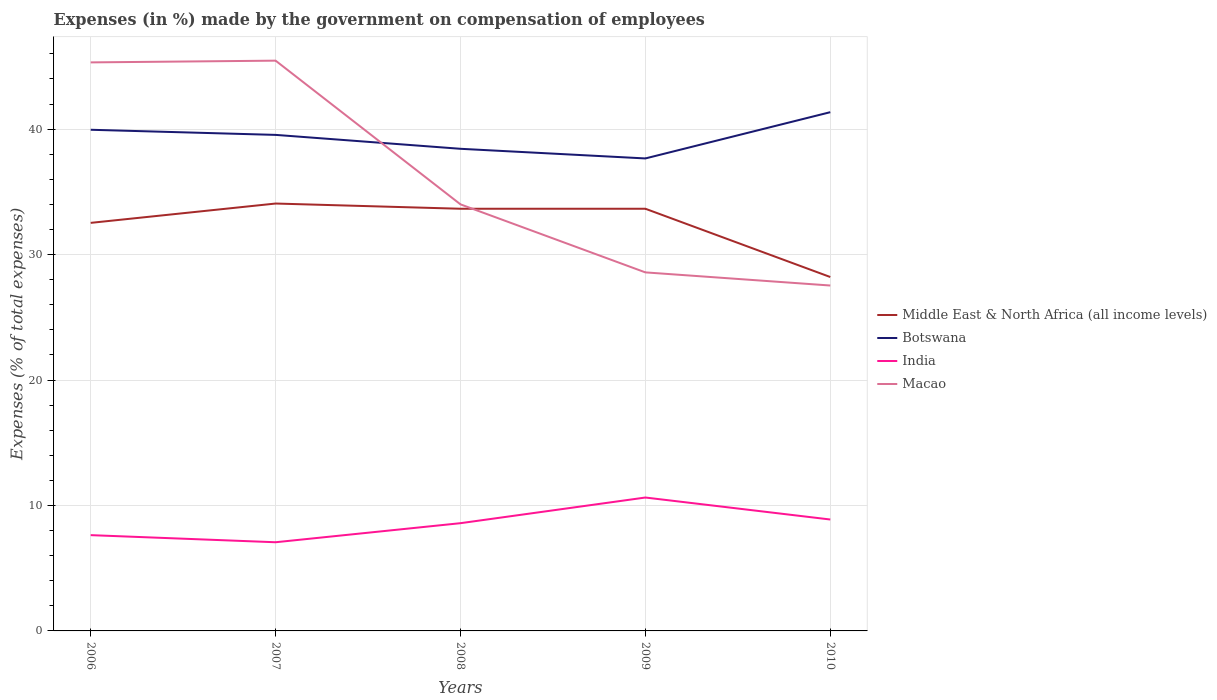Does the line corresponding to Botswana intersect with the line corresponding to Middle East & North Africa (all income levels)?
Offer a terse response. No. Is the number of lines equal to the number of legend labels?
Your response must be concise. Yes. Across all years, what is the maximum percentage of expenses made by the government on compensation of employees in Macao?
Your answer should be very brief. 27.54. What is the total percentage of expenses made by the government on compensation of employees in Botswana in the graph?
Offer a very short reply. 1.88. What is the difference between the highest and the second highest percentage of expenses made by the government on compensation of employees in Middle East & North Africa (all income levels)?
Ensure brevity in your answer.  5.86. What is the difference between the highest and the lowest percentage of expenses made by the government on compensation of employees in Botswana?
Provide a short and direct response. 3. How many lines are there?
Give a very brief answer. 4. Does the graph contain any zero values?
Offer a very short reply. No. Where does the legend appear in the graph?
Provide a succinct answer. Center right. How many legend labels are there?
Ensure brevity in your answer.  4. How are the legend labels stacked?
Make the answer very short. Vertical. What is the title of the graph?
Give a very brief answer. Expenses (in %) made by the government on compensation of employees. What is the label or title of the Y-axis?
Offer a very short reply. Expenses (% of total expenses). What is the Expenses (% of total expenses) of Middle East & North Africa (all income levels) in 2006?
Provide a succinct answer. 32.53. What is the Expenses (% of total expenses) in Botswana in 2006?
Give a very brief answer. 39.95. What is the Expenses (% of total expenses) of India in 2006?
Ensure brevity in your answer.  7.64. What is the Expenses (% of total expenses) of Macao in 2006?
Give a very brief answer. 45.32. What is the Expenses (% of total expenses) in Middle East & North Africa (all income levels) in 2007?
Your response must be concise. 34.07. What is the Expenses (% of total expenses) in Botswana in 2007?
Offer a very short reply. 39.54. What is the Expenses (% of total expenses) in India in 2007?
Your answer should be very brief. 7.07. What is the Expenses (% of total expenses) of Macao in 2007?
Make the answer very short. 45.46. What is the Expenses (% of total expenses) in Middle East & North Africa (all income levels) in 2008?
Your answer should be very brief. 33.65. What is the Expenses (% of total expenses) in Botswana in 2008?
Offer a very short reply. 38.43. What is the Expenses (% of total expenses) in India in 2008?
Ensure brevity in your answer.  8.59. What is the Expenses (% of total expenses) of Macao in 2008?
Your response must be concise. 34. What is the Expenses (% of total expenses) of Middle East & North Africa (all income levels) in 2009?
Make the answer very short. 33.66. What is the Expenses (% of total expenses) in Botswana in 2009?
Offer a very short reply. 37.66. What is the Expenses (% of total expenses) in India in 2009?
Provide a succinct answer. 10.63. What is the Expenses (% of total expenses) in Macao in 2009?
Your answer should be compact. 28.58. What is the Expenses (% of total expenses) in Middle East & North Africa (all income levels) in 2010?
Your response must be concise. 28.21. What is the Expenses (% of total expenses) in Botswana in 2010?
Your answer should be compact. 41.35. What is the Expenses (% of total expenses) of India in 2010?
Give a very brief answer. 8.88. What is the Expenses (% of total expenses) of Macao in 2010?
Your answer should be very brief. 27.54. Across all years, what is the maximum Expenses (% of total expenses) in Middle East & North Africa (all income levels)?
Your answer should be very brief. 34.07. Across all years, what is the maximum Expenses (% of total expenses) of Botswana?
Make the answer very short. 41.35. Across all years, what is the maximum Expenses (% of total expenses) in India?
Your response must be concise. 10.63. Across all years, what is the maximum Expenses (% of total expenses) of Macao?
Offer a terse response. 45.46. Across all years, what is the minimum Expenses (% of total expenses) of Middle East & North Africa (all income levels)?
Your response must be concise. 28.21. Across all years, what is the minimum Expenses (% of total expenses) of Botswana?
Provide a short and direct response. 37.66. Across all years, what is the minimum Expenses (% of total expenses) in India?
Your response must be concise. 7.07. Across all years, what is the minimum Expenses (% of total expenses) of Macao?
Provide a succinct answer. 27.54. What is the total Expenses (% of total expenses) of Middle East & North Africa (all income levels) in the graph?
Ensure brevity in your answer.  162.12. What is the total Expenses (% of total expenses) of Botswana in the graph?
Your answer should be compact. 196.95. What is the total Expenses (% of total expenses) in India in the graph?
Give a very brief answer. 42.81. What is the total Expenses (% of total expenses) in Macao in the graph?
Make the answer very short. 180.9. What is the difference between the Expenses (% of total expenses) of Middle East & North Africa (all income levels) in 2006 and that in 2007?
Your answer should be compact. -1.54. What is the difference between the Expenses (% of total expenses) of Botswana in 2006 and that in 2007?
Your answer should be compact. 0.41. What is the difference between the Expenses (% of total expenses) in India in 2006 and that in 2007?
Offer a very short reply. 0.57. What is the difference between the Expenses (% of total expenses) in Macao in 2006 and that in 2007?
Your response must be concise. -0.14. What is the difference between the Expenses (% of total expenses) in Middle East & North Africa (all income levels) in 2006 and that in 2008?
Make the answer very short. -1.13. What is the difference between the Expenses (% of total expenses) of Botswana in 2006 and that in 2008?
Your answer should be very brief. 1.52. What is the difference between the Expenses (% of total expenses) of India in 2006 and that in 2008?
Offer a terse response. -0.95. What is the difference between the Expenses (% of total expenses) in Macao in 2006 and that in 2008?
Your answer should be compact. 11.32. What is the difference between the Expenses (% of total expenses) of Middle East & North Africa (all income levels) in 2006 and that in 2009?
Offer a terse response. -1.13. What is the difference between the Expenses (% of total expenses) in Botswana in 2006 and that in 2009?
Provide a short and direct response. 2.29. What is the difference between the Expenses (% of total expenses) of India in 2006 and that in 2009?
Offer a terse response. -3. What is the difference between the Expenses (% of total expenses) of Macao in 2006 and that in 2009?
Your answer should be very brief. 16.74. What is the difference between the Expenses (% of total expenses) in Middle East & North Africa (all income levels) in 2006 and that in 2010?
Ensure brevity in your answer.  4.32. What is the difference between the Expenses (% of total expenses) of Botswana in 2006 and that in 2010?
Keep it short and to the point. -1.4. What is the difference between the Expenses (% of total expenses) of India in 2006 and that in 2010?
Ensure brevity in your answer.  -1.25. What is the difference between the Expenses (% of total expenses) of Macao in 2006 and that in 2010?
Your answer should be compact. 17.79. What is the difference between the Expenses (% of total expenses) in Middle East & North Africa (all income levels) in 2007 and that in 2008?
Ensure brevity in your answer.  0.42. What is the difference between the Expenses (% of total expenses) in Botswana in 2007 and that in 2008?
Offer a very short reply. 1.11. What is the difference between the Expenses (% of total expenses) in India in 2007 and that in 2008?
Give a very brief answer. -1.52. What is the difference between the Expenses (% of total expenses) of Macao in 2007 and that in 2008?
Make the answer very short. 11.46. What is the difference between the Expenses (% of total expenses) in Middle East & North Africa (all income levels) in 2007 and that in 2009?
Keep it short and to the point. 0.42. What is the difference between the Expenses (% of total expenses) of Botswana in 2007 and that in 2009?
Give a very brief answer. 1.88. What is the difference between the Expenses (% of total expenses) of India in 2007 and that in 2009?
Provide a short and direct response. -3.56. What is the difference between the Expenses (% of total expenses) in Macao in 2007 and that in 2009?
Provide a succinct answer. 16.88. What is the difference between the Expenses (% of total expenses) of Middle East & North Africa (all income levels) in 2007 and that in 2010?
Your answer should be compact. 5.86. What is the difference between the Expenses (% of total expenses) in Botswana in 2007 and that in 2010?
Provide a short and direct response. -1.81. What is the difference between the Expenses (% of total expenses) in India in 2007 and that in 2010?
Give a very brief answer. -1.81. What is the difference between the Expenses (% of total expenses) in Macao in 2007 and that in 2010?
Ensure brevity in your answer.  17.93. What is the difference between the Expenses (% of total expenses) in Middle East & North Africa (all income levels) in 2008 and that in 2009?
Provide a succinct answer. -0. What is the difference between the Expenses (% of total expenses) in Botswana in 2008 and that in 2009?
Provide a succinct answer. 0.77. What is the difference between the Expenses (% of total expenses) of India in 2008 and that in 2009?
Provide a succinct answer. -2.04. What is the difference between the Expenses (% of total expenses) in Macao in 2008 and that in 2009?
Provide a succinct answer. 5.42. What is the difference between the Expenses (% of total expenses) of Middle East & North Africa (all income levels) in 2008 and that in 2010?
Your answer should be compact. 5.44. What is the difference between the Expenses (% of total expenses) in Botswana in 2008 and that in 2010?
Offer a terse response. -2.92. What is the difference between the Expenses (% of total expenses) in India in 2008 and that in 2010?
Provide a short and direct response. -0.29. What is the difference between the Expenses (% of total expenses) in Macao in 2008 and that in 2010?
Provide a succinct answer. 6.47. What is the difference between the Expenses (% of total expenses) in Middle East & North Africa (all income levels) in 2009 and that in 2010?
Your answer should be compact. 5.44. What is the difference between the Expenses (% of total expenses) of Botswana in 2009 and that in 2010?
Your answer should be very brief. -3.69. What is the difference between the Expenses (% of total expenses) of India in 2009 and that in 2010?
Offer a terse response. 1.75. What is the difference between the Expenses (% of total expenses) of Macao in 2009 and that in 2010?
Give a very brief answer. 1.05. What is the difference between the Expenses (% of total expenses) in Middle East & North Africa (all income levels) in 2006 and the Expenses (% of total expenses) in Botswana in 2007?
Keep it short and to the point. -7.01. What is the difference between the Expenses (% of total expenses) of Middle East & North Africa (all income levels) in 2006 and the Expenses (% of total expenses) of India in 2007?
Ensure brevity in your answer.  25.46. What is the difference between the Expenses (% of total expenses) in Middle East & North Africa (all income levels) in 2006 and the Expenses (% of total expenses) in Macao in 2007?
Give a very brief answer. -12.93. What is the difference between the Expenses (% of total expenses) in Botswana in 2006 and the Expenses (% of total expenses) in India in 2007?
Your response must be concise. 32.88. What is the difference between the Expenses (% of total expenses) in Botswana in 2006 and the Expenses (% of total expenses) in Macao in 2007?
Make the answer very short. -5.51. What is the difference between the Expenses (% of total expenses) of India in 2006 and the Expenses (% of total expenses) of Macao in 2007?
Provide a succinct answer. -37.83. What is the difference between the Expenses (% of total expenses) of Middle East & North Africa (all income levels) in 2006 and the Expenses (% of total expenses) of Botswana in 2008?
Your answer should be very brief. -5.9. What is the difference between the Expenses (% of total expenses) of Middle East & North Africa (all income levels) in 2006 and the Expenses (% of total expenses) of India in 2008?
Your answer should be compact. 23.94. What is the difference between the Expenses (% of total expenses) in Middle East & North Africa (all income levels) in 2006 and the Expenses (% of total expenses) in Macao in 2008?
Offer a terse response. -1.47. What is the difference between the Expenses (% of total expenses) in Botswana in 2006 and the Expenses (% of total expenses) in India in 2008?
Keep it short and to the point. 31.36. What is the difference between the Expenses (% of total expenses) of Botswana in 2006 and the Expenses (% of total expenses) of Macao in 2008?
Offer a terse response. 5.95. What is the difference between the Expenses (% of total expenses) in India in 2006 and the Expenses (% of total expenses) in Macao in 2008?
Ensure brevity in your answer.  -26.37. What is the difference between the Expenses (% of total expenses) in Middle East & North Africa (all income levels) in 2006 and the Expenses (% of total expenses) in Botswana in 2009?
Give a very brief answer. -5.14. What is the difference between the Expenses (% of total expenses) in Middle East & North Africa (all income levels) in 2006 and the Expenses (% of total expenses) in India in 2009?
Provide a short and direct response. 21.9. What is the difference between the Expenses (% of total expenses) in Middle East & North Africa (all income levels) in 2006 and the Expenses (% of total expenses) in Macao in 2009?
Offer a terse response. 3.95. What is the difference between the Expenses (% of total expenses) in Botswana in 2006 and the Expenses (% of total expenses) in India in 2009?
Offer a terse response. 29.32. What is the difference between the Expenses (% of total expenses) of Botswana in 2006 and the Expenses (% of total expenses) of Macao in 2009?
Provide a succinct answer. 11.37. What is the difference between the Expenses (% of total expenses) of India in 2006 and the Expenses (% of total expenses) of Macao in 2009?
Your answer should be compact. -20.95. What is the difference between the Expenses (% of total expenses) of Middle East & North Africa (all income levels) in 2006 and the Expenses (% of total expenses) of Botswana in 2010?
Your answer should be very brief. -8.82. What is the difference between the Expenses (% of total expenses) in Middle East & North Africa (all income levels) in 2006 and the Expenses (% of total expenses) in India in 2010?
Provide a succinct answer. 23.65. What is the difference between the Expenses (% of total expenses) of Middle East & North Africa (all income levels) in 2006 and the Expenses (% of total expenses) of Macao in 2010?
Offer a very short reply. 4.99. What is the difference between the Expenses (% of total expenses) of Botswana in 2006 and the Expenses (% of total expenses) of India in 2010?
Your response must be concise. 31.07. What is the difference between the Expenses (% of total expenses) of Botswana in 2006 and the Expenses (% of total expenses) of Macao in 2010?
Provide a succinct answer. 12.42. What is the difference between the Expenses (% of total expenses) of India in 2006 and the Expenses (% of total expenses) of Macao in 2010?
Provide a succinct answer. -19.9. What is the difference between the Expenses (% of total expenses) of Middle East & North Africa (all income levels) in 2007 and the Expenses (% of total expenses) of Botswana in 2008?
Offer a terse response. -4.36. What is the difference between the Expenses (% of total expenses) of Middle East & North Africa (all income levels) in 2007 and the Expenses (% of total expenses) of India in 2008?
Offer a very short reply. 25.48. What is the difference between the Expenses (% of total expenses) of Middle East & North Africa (all income levels) in 2007 and the Expenses (% of total expenses) of Macao in 2008?
Your answer should be very brief. 0.07. What is the difference between the Expenses (% of total expenses) in Botswana in 2007 and the Expenses (% of total expenses) in India in 2008?
Ensure brevity in your answer.  30.95. What is the difference between the Expenses (% of total expenses) of Botswana in 2007 and the Expenses (% of total expenses) of Macao in 2008?
Your answer should be very brief. 5.54. What is the difference between the Expenses (% of total expenses) in India in 2007 and the Expenses (% of total expenses) in Macao in 2008?
Offer a very short reply. -26.93. What is the difference between the Expenses (% of total expenses) of Middle East & North Africa (all income levels) in 2007 and the Expenses (% of total expenses) of Botswana in 2009?
Make the answer very short. -3.59. What is the difference between the Expenses (% of total expenses) in Middle East & North Africa (all income levels) in 2007 and the Expenses (% of total expenses) in India in 2009?
Offer a very short reply. 23.44. What is the difference between the Expenses (% of total expenses) of Middle East & North Africa (all income levels) in 2007 and the Expenses (% of total expenses) of Macao in 2009?
Your answer should be very brief. 5.49. What is the difference between the Expenses (% of total expenses) in Botswana in 2007 and the Expenses (% of total expenses) in India in 2009?
Provide a succinct answer. 28.91. What is the difference between the Expenses (% of total expenses) of Botswana in 2007 and the Expenses (% of total expenses) of Macao in 2009?
Give a very brief answer. 10.96. What is the difference between the Expenses (% of total expenses) in India in 2007 and the Expenses (% of total expenses) in Macao in 2009?
Keep it short and to the point. -21.51. What is the difference between the Expenses (% of total expenses) of Middle East & North Africa (all income levels) in 2007 and the Expenses (% of total expenses) of Botswana in 2010?
Ensure brevity in your answer.  -7.28. What is the difference between the Expenses (% of total expenses) in Middle East & North Africa (all income levels) in 2007 and the Expenses (% of total expenses) in India in 2010?
Ensure brevity in your answer.  25.19. What is the difference between the Expenses (% of total expenses) of Middle East & North Africa (all income levels) in 2007 and the Expenses (% of total expenses) of Macao in 2010?
Keep it short and to the point. 6.54. What is the difference between the Expenses (% of total expenses) of Botswana in 2007 and the Expenses (% of total expenses) of India in 2010?
Provide a short and direct response. 30.66. What is the difference between the Expenses (% of total expenses) in Botswana in 2007 and the Expenses (% of total expenses) in Macao in 2010?
Offer a very short reply. 12.01. What is the difference between the Expenses (% of total expenses) in India in 2007 and the Expenses (% of total expenses) in Macao in 2010?
Keep it short and to the point. -20.47. What is the difference between the Expenses (% of total expenses) in Middle East & North Africa (all income levels) in 2008 and the Expenses (% of total expenses) in Botswana in 2009?
Give a very brief answer. -4.01. What is the difference between the Expenses (% of total expenses) in Middle East & North Africa (all income levels) in 2008 and the Expenses (% of total expenses) in India in 2009?
Ensure brevity in your answer.  23.02. What is the difference between the Expenses (% of total expenses) of Middle East & North Africa (all income levels) in 2008 and the Expenses (% of total expenses) of Macao in 2009?
Ensure brevity in your answer.  5.07. What is the difference between the Expenses (% of total expenses) in Botswana in 2008 and the Expenses (% of total expenses) in India in 2009?
Your answer should be very brief. 27.8. What is the difference between the Expenses (% of total expenses) in Botswana in 2008 and the Expenses (% of total expenses) in Macao in 2009?
Your response must be concise. 9.85. What is the difference between the Expenses (% of total expenses) in India in 2008 and the Expenses (% of total expenses) in Macao in 2009?
Provide a succinct answer. -19.99. What is the difference between the Expenses (% of total expenses) in Middle East & North Africa (all income levels) in 2008 and the Expenses (% of total expenses) in Botswana in 2010?
Provide a short and direct response. -7.7. What is the difference between the Expenses (% of total expenses) of Middle East & North Africa (all income levels) in 2008 and the Expenses (% of total expenses) of India in 2010?
Ensure brevity in your answer.  24.77. What is the difference between the Expenses (% of total expenses) of Middle East & North Africa (all income levels) in 2008 and the Expenses (% of total expenses) of Macao in 2010?
Ensure brevity in your answer.  6.12. What is the difference between the Expenses (% of total expenses) of Botswana in 2008 and the Expenses (% of total expenses) of India in 2010?
Your response must be concise. 29.55. What is the difference between the Expenses (% of total expenses) of Botswana in 2008 and the Expenses (% of total expenses) of Macao in 2010?
Your response must be concise. 10.9. What is the difference between the Expenses (% of total expenses) in India in 2008 and the Expenses (% of total expenses) in Macao in 2010?
Offer a very short reply. -18.95. What is the difference between the Expenses (% of total expenses) in Middle East & North Africa (all income levels) in 2009 and the Expenses (% of total expenses) in Botswana in 2010?
Give a very brief answer. -7.7. What is the difference between the Expenses (% of total expenses) of Middle East & North Africa (all income levels) in 2009 and the Expenses (% of total expenses) of India in 2010?
Ensure brevity in your answer.  24.77. What is the difference between the Expenses (% of total expenses) of Middle East & North Africa (all income levels) in 2009 and the Expenses (% of total expenses) of Macao in 2010?
Ensure brevity in your answer.  6.12. What is the difference between the Expenses (% of total expenses) in Botswana in 2009 and the Expenses (% of total expenses) in India in 2010?
Provide a succinct answer. 28.78. What is the difference between the Expenses (% of total expenses) in Botswana in 2009 and the Expenses (% of total expenses) in Macao in 2010?
Your answer should be very brief. 10.13. What is the difference between the Expenses (% of total expenses) of India in 2009 and the Expenses (% of total expenses) of Macao in 2010?
Make the answer very short. -16.9. What is the average Expenses (% of total expenses) in Middle East & North Africa (all income levels) per year?
Make the answer very short. 32.42. What is the average Expenses (% of total expenses) in Botswana per year?
Ensure brevity in your answer.  39.39. What is the average Expenses (% of total expenses) of India per year?
Your response must be concise. 8.56. What is the average Expenses (% of total expenses) in Macao per year?
Make the answer very short. 36.18. In the year 2006, what is the difference between the Expenses (% of total expenses) in Middle East & North Africa (all income levels) and Expenses (% of total expenses) in Botswana?
Your response must be concise. -7.42. In the year 2006, what is the difference between the Expenses (% of total expenses) in Middle East & North Africa (all income levels) and Expenses (% of total expenses) in India?
Provide a short and direct response. 24.89. In the year 2006, what is the difference between the Expenses (% of total expenses) of Middle East & North Africa (all income levels) and Expenses (% of total expenses) of Macao?
Your answer should be compact. -12.79. In the year 2006, what is the difference between the Expenses (% of total expenses) in Botswana and Expenses (% of total expenses) in India?
Provide a succinct answer. 32.32. In the year 2006, what is the difference between the Expenses (% of total expenses) in Botswana and Expenses (% of total expenses) in Macao?
Your response must be concise. -5.37. In the year 2006, what is the difference between the Expenses (% of total expenses) of India and Expenses (% of total expenses) of Macao?
Offer a very short reply. -37.69. In the year 2007, what is the difference between the Expenses (% of total expenses) of Middle East & North Africa (all income levels) and Expenses (% of total expenses) of Botswana?
Provide a succinct answer. -5.47. In the year 2007, what is the difference between the Expenses (% of total expenses) of Middle East & North Africa (all income levels) and Expenses (% of total expenses) of India?
Provide a short and direct response. 27. In the year 2007, what is the difference between the Expenses (% of total expenses) in Middle East & North Africa (all income levels) and Expenses (% of total expenses) in Macao?
Offer a terse response. -11.39. In the year 2007, what is the difference between the Expenses (% of total expenses) in Botswana and Expenses (% of total expenses) in India?
Make the answer very short. 32.47. In the year 2007, what is the difference between the Expenses (% of total expenses) of Botswana and Expenses (% of total expenses) of Macao?
Your answer should be very brief. -5.92. In the year 2007, what is the difference between the Expenses (% of total expenses) in India and Expenses (% of total expenses) in Macao?
Your answer should be very brief. -38.39. In the year 2008, what is the difference between the Expenses (% of total expenses) of Middle East & North Africa (all income levels) and Expenses (% of total expenses) of Botswana?
Offer a terse response. -4.78. In the year 2008, what is the difference between the Expenses (% of total expenses) in Middle East & North Africa (all income levels) and Expenses (% of total expenses) in India?
Offer a very short reply. 25.07. In the year 2008, what is the difference between the Expenses (% of total expenses) in Middle East & North Africa (all income levels) and Expenses (% of total expenses) in Macao?
Your answer should be very brief. -0.35. In the year 2008, what is the difference between the Expenses (% of total expenses) of Botswana and Expenses (% of total expenses) of India?
Provide a short and direct response. 29.84. In the year 2008, what is the difference between the Expenses (% of total expenses) of Botswana and Expenses (% of total expenses) of Macao?
Make the answer very short. 4.43. In the year 2008, what is the difference between the Expenses (% of total expenses) in India and Expenses (% of total expenses) in Macao?
Your answer should be compact. -25.42. In the year 2009, what is the difference between the Expenses (% of total expenses) in Middle East & North Africa (all income levels) and Expenses (% of total expenses) in Botswana?
Provide a short and direct response. -4.01. In the year 2009, what is the difference between the Expenses (% of total expenses) in Middle East & North Africa (all income levels) and Expenses (% of total expenses) in India?
Make the answer very short. 23.02. In the year 2009, what is the difference between the Expenses (% of total expenses) in Middle East & North Africa (all income levels) and Expenses (% of total expenses) in Macao?
Offer a terse response. 5.07. In the year 2009, what is the difference between the Expenses (% of total expenses) in Botswana and Expenses (% of total expenses) in India?
Give a very brief answer. 27.03. In the year 2009, what is the difference between the Expenses (% of total expenses) in Botswana and Expenses (% of total expenses) in Macao?
Keep it short and to the point. 9.08. In the year 2009, what is the difference between the Expenses (% of total expenses) in India and Expenses (% of total expenses) in Macao?
Make the answer very short. -17.95. In the year 2010, what is the difference between the Expenses (% of total expenses) of Middle East & North Africa (all income levels) and Expenses (% of total expenses) of Botswana?
Your answer should be very brief. -13.14. In the year 2010, what is the difference between the Expenses (% of total expenses) in Middle East & North Africa (all income levels) and Expenses (% of total expenses) in India?
Ensure brevity in your answer.  19.33. In the year 2010, what is the difference between the Expenses (% of total expenses) in Middle East & North Africa (all income levels) and Expenses (% of total expenses) in Macao?
Provide a succinct answer. 0.68. In the year 2010, what is the difference between the Expenses (% of total expenses) in Botswana and Expenses (% of total expenses) in India?
Offer a very short reply. 32.47. In the year 2010, what is the difference between the Expenses (% of total expenses) of Botswana and Expenses (% of total expenses) of Macao?
Offer a very short reply. 13.82. In the year 2010, what is the difference between the Expenses (% of total expenses) of India and Expenses (% of total expenses) of Macao?
Offer a terse response. -18.65. What is the ratio of the Expenses (% of total expenses) in Middle East & North Africa (all income levels) in 2006 to that in 2007?
Give a very brief answer. 0.95. What is the ratio of the Expenses (% of total expenses) of Botswana in 2006 to that in 2007?
Provide a short and direct response. 1.01. What is the ratio of the Expenses (% of total expenses) of India in 2006 to that in 2007?
Provide a short and direct response. 1.08. What is the ratio of the Expenses (% of total expenses) in Macao in 2006 to that in 2007?
Offer a very short reply. 1. What is the ratio of the Expenses (% of total expenses) in Middle East & North Africa (all income levels) in 2006 to that in 2008?
Give a very brief answer. 0.97. What is the ratio of the Expenses (% of total expenses) of Botswana in 2006 to that in 2008?
Offer a terse response. 1.04. What is the ratio of the Expenses (% of total expenses) in India in 2006 to that in 2008?
Offer a very short reply. 0.89. What is the ratio of the Expenses (% of total expenses) in Macao in 2006 to that in 2008?
Provide a succinct answer. 1.33. What is the ratio of the Expenses (% of total expenses) in Middle East & North Africa (all income levels) in 2006 to that in 2009?
Your answer should be compact. 0.97. What is the ratio of the Expenses (% of total expenses) in Botswana in 2006 to that in 2009?
Your answer should be compact. 1.06. What is the ratio of the Expenses (% of total expenses) in India in 2006 to that in 2009?
Your answer should be compact. 0.72. What is the ratio of the Expenses (% of total expenses) in Macao in 2006 to that in 2009?
Your answer should be compact. 1.59. What is the ratio of the Expenses (% of total expenses) in Middle East & North Africa (all income levels) in 2006 to that in 2010?
Ensure brevity in your answer.  1.15. What is the ratio of the Expenses (% of total expenses) in Botswana in 2006 to that in 2010?
Make the answer very short. 0.97. What is the ratio of the Expenses (% of total expenses) of India in 2006 to that in 2010?
Your response must be concise. 0.86. What is the ratio of the Expenses (% of total expenses) of Macao in 2006 to that in 2010?
Keep it short and to the point. 1.65. What is the ratio of the Expenses (% of total expenses) of Middle East & North Africa (all income levels) in 2007 to that in 2008?
Your answer should be compact. 1.01. What is the ratio of the Expenses (% of total expenses) in Botswana in 2007 to that in 2008?
Offer a terse response. 1.03. What is the ratio of the Expenses (% of total expenses) of India in 2007 to that in 2008?
Provide a succinct answer. 0.82. What is the ratio of the Expenses (% of total expenses) in Macao in 2007 to that in 2008?
Your response must be concise. 1.34. What is the ratio of the Expenses (% of total expenses) in Middle East & North Africa (all income levels) in 2007 to that in 2009?
Keep it short and to the point. 1.01. What is the ratio of the Expenses (% of total expenses) in Botswana in 2007 to that in 2009?
Keep it short and to the point. 1.05. What is the ratio of the Expenses (% of total expenses) in India in 2007 to that in 2009?
Your answer should be compact. 0.66. What is the ratio of the Expenses (% of total expenses) of Macao in 2007 to that in 2009?
Your answer should be very brief. 1.59. What is the ratio of the Expenses (% of total expenses) of Middle East & North Africa (all income levels) in 2007 to that in 2010?
Offer a very short reply. 1.21. What is the ratio of the Expenses (% of total expenses) of Botswana in 2007 to that in 2010?
Ensure brevity in your answer.  0.96. What is the ratio of the Expenses (% of total expenses) of India in 2007 to that in 2010?
Keep it short and to the point. 0.8. What is the ratio of the Expenses (% of total expenses) in Macao in 2007 to that in 2010?
Your answer should be very brief. 1.65. What is the ratio of the Expenses (% of total expenses) in Middle East & North Africa (all income levels) in 2008 to that in 2009?
Give a very brief answer. 1. What is the ratio of the Expenses (% of total expenses) in Botswana in 2008 to that in 2009?
Your answer should be very brief. 1.02. What is the ratio of the Expenses (% of total expenses) in India in 2008 to that in 2009?
Give a very brief answer. 0.81. What is the ratio of the Expenses (% of total expenses) of Macao in 2008 to that in 2009?
Provide a short and direct response. 1.19. What is the ratio of the Expenses (% of total expenses) in Middle East & North Africa (all income levels) in 2008 to that in 2010?
Offer a very short reply. 1.19. What is the ratio of the Expenses (% of total expenses) of Botswana in 2008 to that in 2010?
Make the answer very short. 0.93. What is the ratio of the Expenses (% of total expenses) in India in 2008 to that in 2010?
Your answer should be very brief. 0.97. What is the ratio of the Expenses (% of total expenses) of Macao in 2008 to that in 2010?
Your response must be concise. 1.23. What is the ratio of the Expenses (% of total expenses) of Middle East & North Africa (all income levels) in 2009 to that in 2010?
Offer a terse response. 1.19. What is the ratio of the Expenses (% of total expenses) in Botswana in 2009 to that in 2010?
Your answer should be very brief. 0.91. What is the ratio of the Expenses (% of total expenses) in India in 2009 to that in 2010?
Your response must be concise. 1.2. What is the ratio of the Expenses (% of total expenses) in Macao in 2009 to that in 2010?
Provide a short and direct response. 1.04. What is the difference between the highest and the second highest Expenses (% of total expenses) in Middle East & North Africa (all income levels)?
Provide a succinct answer. 0.42. What is the difference between the highest and the second highest Expenses (% of total expenses) in Botswana?
Make the answer very short. 1.4. What is the difference between the highest and the second highest Expenses (% of total expenses) of India?
Make the answer very short. 1.75. What is the difference between the highest and the second highest Expenses (% of total expenses) in Macao?
Your answer should be very brief. 0.14. What is the difference between the highest and the lowest Expenses (% of total expenses) of Middle East & North Africa (all income levels)?
Ensure brevity in your answer.  5.86. What is the difference between the highest and the lowest Expenses (% of total expenses) of Botswana?
Provide a succinct answer. 3.69. What is the difference between the highest and the lowest Expenses (% of total expenses) of India?
Your answer should be compact. 3.56. What is the difference between the highest and the lowest Expenses (% of total expenses) of Macao?
Keep it short and to the point. 17.93. 